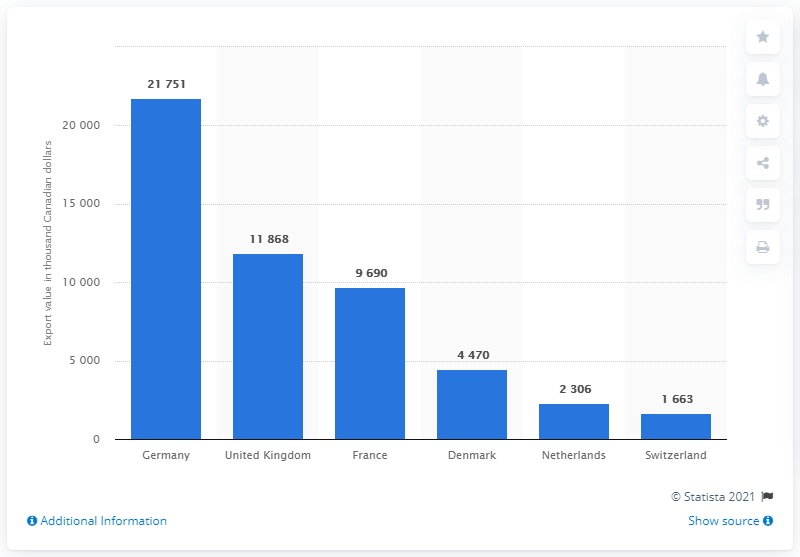Outline some significant characteristics in this image. In 2013, Germany was the leading export destination for maple sugar and maple syrup from Canada. 